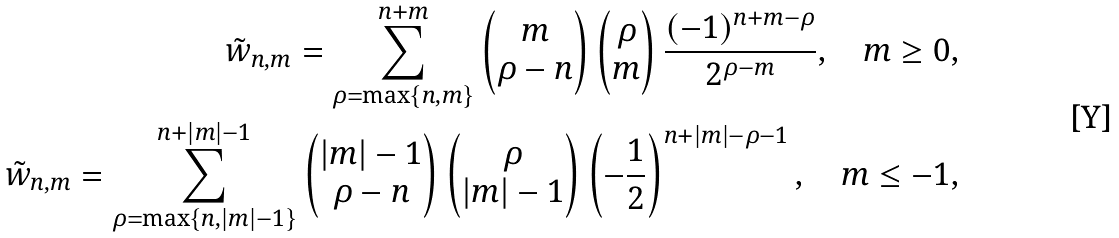<formula> <loc_0><loc_0><loc_500><loc_500>\tilde { w } _ { n , m } = \sum _ { \rho = \max \{ n , m \} } ^ { n + m } \begin{pmatrix} m \\ \rho - n \end{pmatrix} \begin{pmatrix} \rho \\ m \end{pmatrix} \frac { ( - 1 ) ^ { n + m - \rho } } { 2 ^ { \rho - m } } , \quad m \geq 0 , \\ \tilde { w } _ { n , m } = \sum _ { \rho = \max \{ n , | m | - 1 \} } ^ { n + | m | - 1 } \begin{pmatrix} | m | - 1 \\ \rho - n \end{pmatrix} \begin{pmatrix} \rho \\ | m | - 1 \end{pmatrix} \left ( - \frac { 1 } { 2 } \right ) ^ { n + | m | - \rho - 1 } , \quad m \leq - 1 ,</formula> 